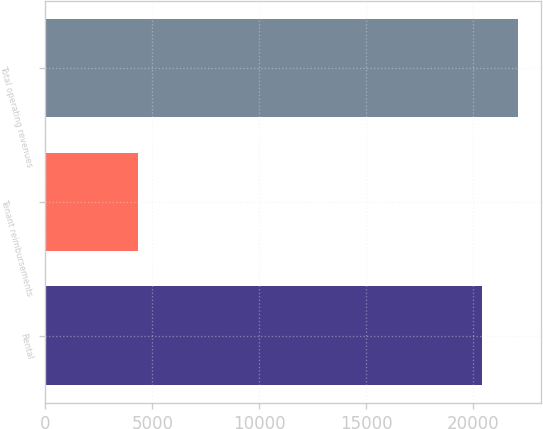<chart> <loc_0><loc_0><loc_500><loc_500><bar_chart><fcel>Rental<fcel>Tenant reimbursements<fcel>Total operating revenues<nl><fcel>20410<fcel>4354<fcel>22076.2<nl></chart> 